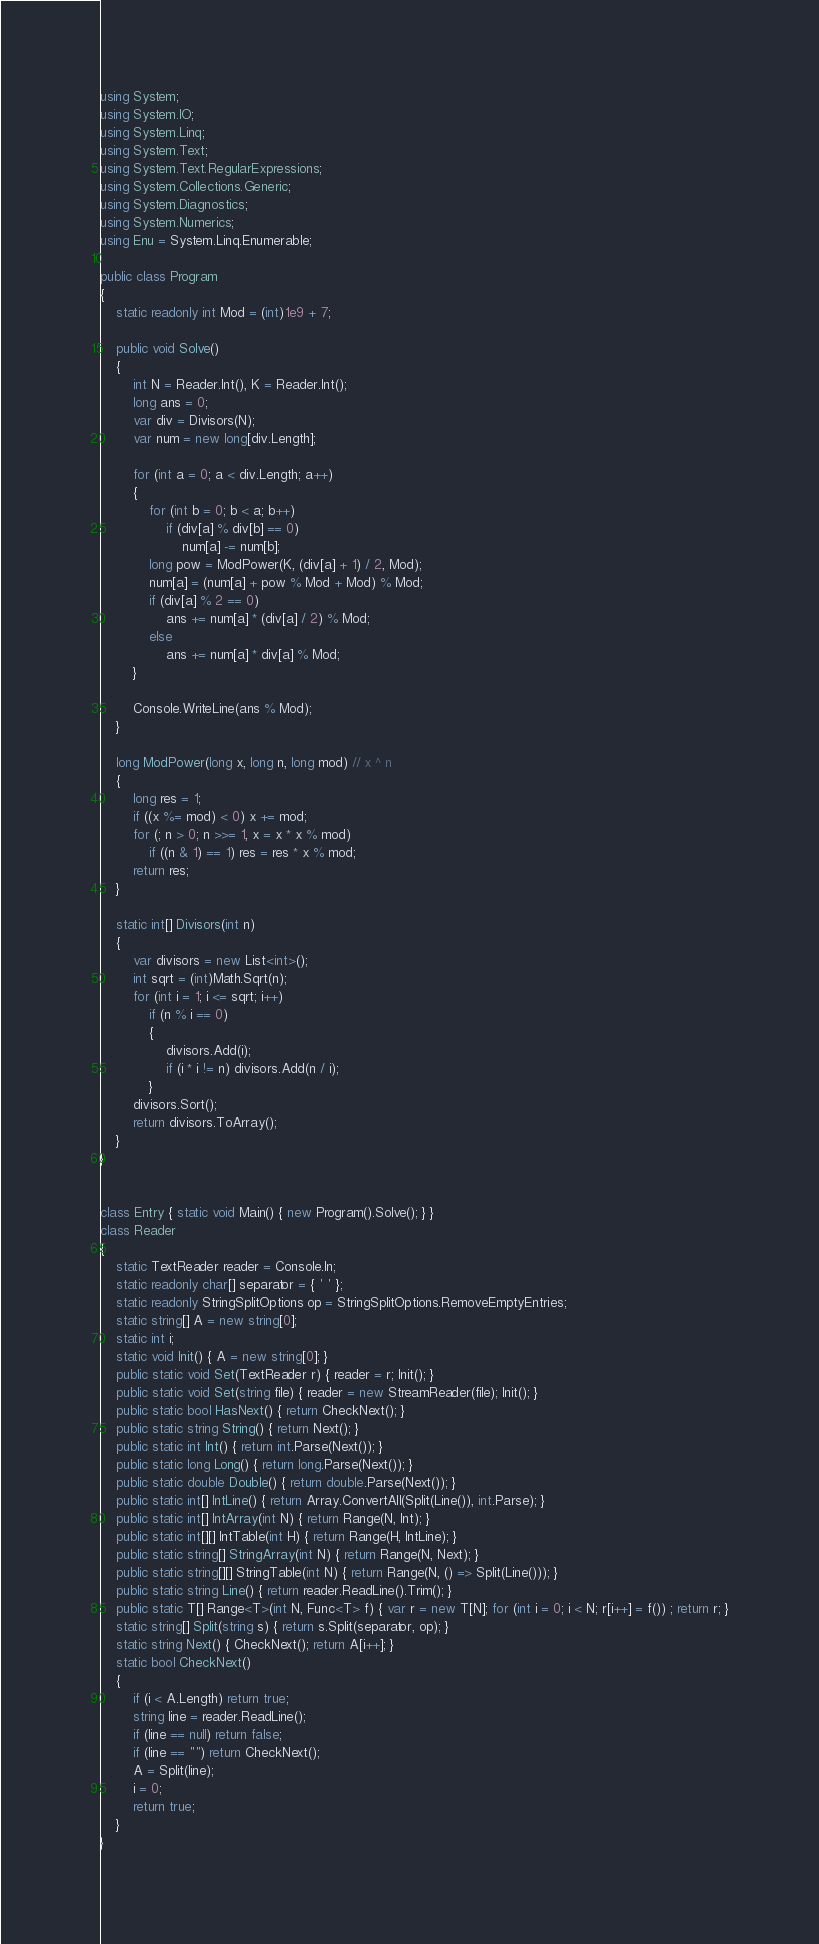<code> <loc_0><loc_0><loc_500><loc_500><_C#_>using System;
using System.IO;
using System.Linq;
using System.Text;
using System.Text.RegularExpressions;
using System.Collections.Generic;
using System.Diagnostics;
using System.Numerics;
using Enu = System.Linq.Enumerable;

public class Program
{
    static readonly int Mod = (int)1e9 + 7;

    public void Solve()
    {
        int N = Reader.Int(), K = Reader.Int();
        long ans = 0;
        var div = Divisors(N);
        var num = new long[div.Length];

        for (int a = 0; a < div.Length; a++)
        {
            for (int b = 0; b < a; b++)
                if (div[a] % div[b] == 0)
                    num[a] -= num[b];
            long pow = ModPower(K, (div[a] + 1) / 2, Mod);
            num[a] = (num[a] + pow % Mod + Mod) % Mod;
            if (div[a] % 2 == 0)
                ans += num[a] * (div[a] / 2) % Mod;
            else
                ans += num[a] * div[a] % Mod;
        }

        Console.WriteLine(ans % Mod);
    }

    long ModPower(long x, long n, long mod) // x ^ n
    {
        long res = 1;
        if ((x %= mod) < 0) x += mod;
        for (; n > 0; n >>= 1, x = x * x % mod)
            if ((n & 1) == 1) res = res * x % mod;
        return res;
    }

    static int[] Divisors(int n)
    {
        var divisors = new List<int>();
        int sqrt = (int)Math.Sqrt(n);
        for (int i = 1; i <= sqrt; i++)
            if (n % i == 0)
            {
                divisors.Add(i);
                if (i * i != n) divisors.Add(n / i);
            }
        divisors.Sort();
        return divisors.ToArray();
    }
}


class Entry { static void Main() { new Program().Solve(); } }
class Reader
{
    static TextReader reader = Console.In;
    static readonly char[] separator = { ' ' };
    static readonly StringSplitOptions op = StringSplitOptions.RemoveEmptyEntries;
    static string[] A = new string[0];
    static int i;
    static void Init() { A = new string[0]; }
    public static void Set(TextReader r) { reader = r; Init(); }
    public static void Set(string file) { reader = new StreamReader(file); Init(); }
    public static bool HasNext() { return CheckNext(); }
    public static string String() { return Next(); }
    public static int Int() { return int.Parse(Next()); }
    public static long Long() { return long.Parse(Next()); }
    public static double Double() { return double.Parse(Next()); }
    public static int[] IntLine() { return Array.ConvertAll(Split(Line()), int.Parse); }
    public static int[] IntArray(int N) { return Range(N, Int); }
    public static int[][] IntTable(int H) { return Range(H, IntLine); }
    public static string[] StringArray(int N) { return Range(N, Next); }
    public static string[][] StringTable(int N) { return Range(N, () => Split(Line())); }
    public static string Line() { return reader.ReadLine().Trim(); }
    public static T[] Range<T>(int N, Func<T> f) { var r = new T[N]; for (int i = 0; i < N; r[i++] = f()) ; return r; }
    static string[] Split(string s) { return s.Split(separator, op); }
    static string Next() { CheckNext(); return A[i++]; }
    static bool CheckNext()
    {
        if (i < A.Length) return true;
        string line = reader.ReadLine();
        if (line == null) return false;
        if (line == "") return CheckNext();
        A = Split(line);
        i = 0;
        return true;
    }
}</code> 